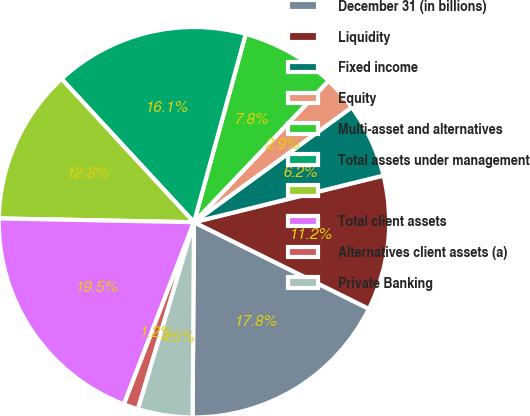Convert chart to OTSL. <chart><loc_0><loc_0><loc_500><loc_500><pie_chart><fcel>December 31 (in billions)<fcel>Liquidity<fcel>Fixed income<fcel>Equity<fcel>Multi-asset and alternatives<fcel>Total assets under management<fcel>Unnamed: 6<fcel>Total client assets<fcel>Alternatives client assets (a)<fcel>Private Banking<nl><fcel>17.8%<fcel>11.16%<fcel>6.18%<fcel>2.87%<fcel>7.84%<fcel>16.14%<fcel>12.82%<fcel>19.46%<fcel>1.21%<fcel>4.52%<nl></chart> 